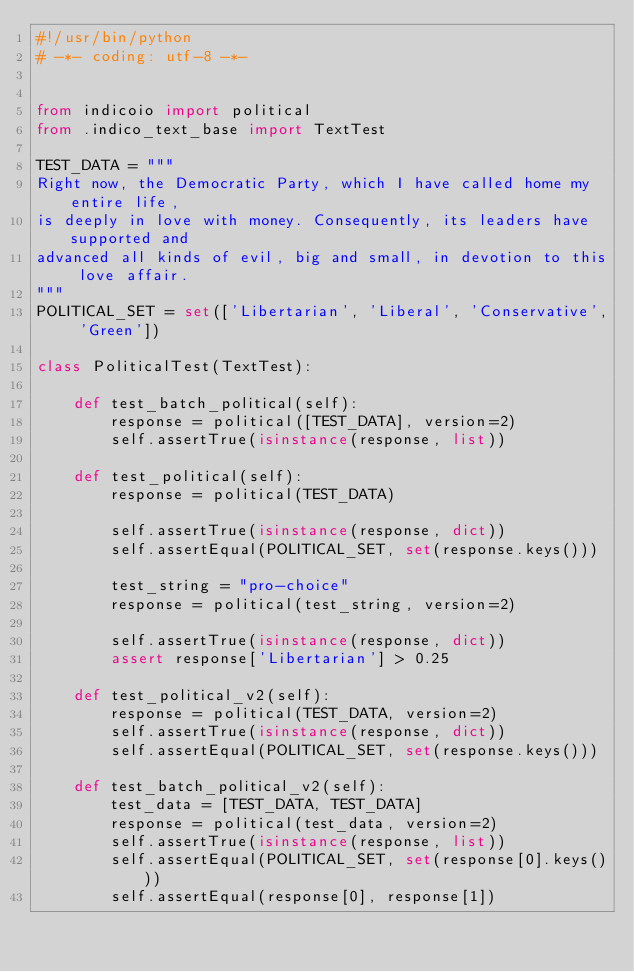<code> <loc_0><loc_0><loc_500><loc_500><_Python_>#!/usr/bin/python
# -*- coding: utf-8 -*-


from indicoio import political
from .indico_text_base import TextTest

TEST_DATA = """
Right now, the Democratic Party, which I have called home my entire life,
is deeply in love with money. Consequently, its leaders have supported and
advanced all kinds of evil, big and small, in devotion to this love affair.
"""
POLITICAL_SET = set(['Libertarian', 'Liberal', 'Conservative', 'Green'])

class PoliticalTest(TextTest):

    def test_batch_political(self):
        response = political([TEST_DATA], version=2)
        self.assertTrue(isinstance(response, list))

    def test_political(self):
        response = political(TEST_DATA)

        self.assertTrue(isinstance(response, dict))
        self.assertEqual(POLITICAL_SET, set(response.keys()))

        test_string = "pro-choice"
        response = political(test_string, version=2)

        self.assertTrue(isinstance(response, dict))
        assert response['Libertarian'] > 0.25

    def test_political_v2(self):
        response = political(TEST_DATA, version=2)
        self.assertTrue(isinstance(response, dict))
        self.assertEqual(POLITICAL_SET, set(response.keys()))

    def test_batch_political_v2(self):
        test_data = [TEST_DATA, TEST_DATA]
        response = political(test_data, version=2)
        self.assertTrue(isinstance(response, list))
        self.assertEqual(POLITICAL_SET, set(response[0].keys()))
        self.assertEqual(response[0], response[1])
</code> 